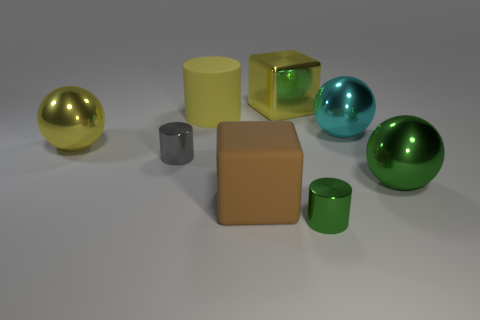The yellow cylinder is what size?
Offer a very short reply. Large. There is a block that is the same material as the yellow cylinder; what is its color?
Make the answer very short. Brown. How many large yellow objects have the same material as the big brown block?
Provide a short and direct response. 1. What number of objects are green things or shiny objects behind the green cylinder?
Keep it short and to the point. 6. Do the large yellow thing that is behind the yellow matte cylinder and the small gray thing have the same material?
Make the answer very short. Yes. There is a metallic block that is the same size as the yellow rubber object; what color is it?
Your answer should be very brief. Yellow. Is there another big green metallic object of the same shape as the big green metallic thing?
Provide a succinct answer. No. There is a tiny thing behind the tiny thing in front of the metal object to the right of the cyan shiny object; what color is it?
Ensure brevity in your answer.  Gray. What number of metal objects are either large yellow balls or tiny gray cylinders?
Offer a terse response. 2. Is the number of small metal things that are on the left side of the green metallic cylinder greater than the number of matte cubes that are left of the rubber cylinder?
Offer a terse response. Yes. 